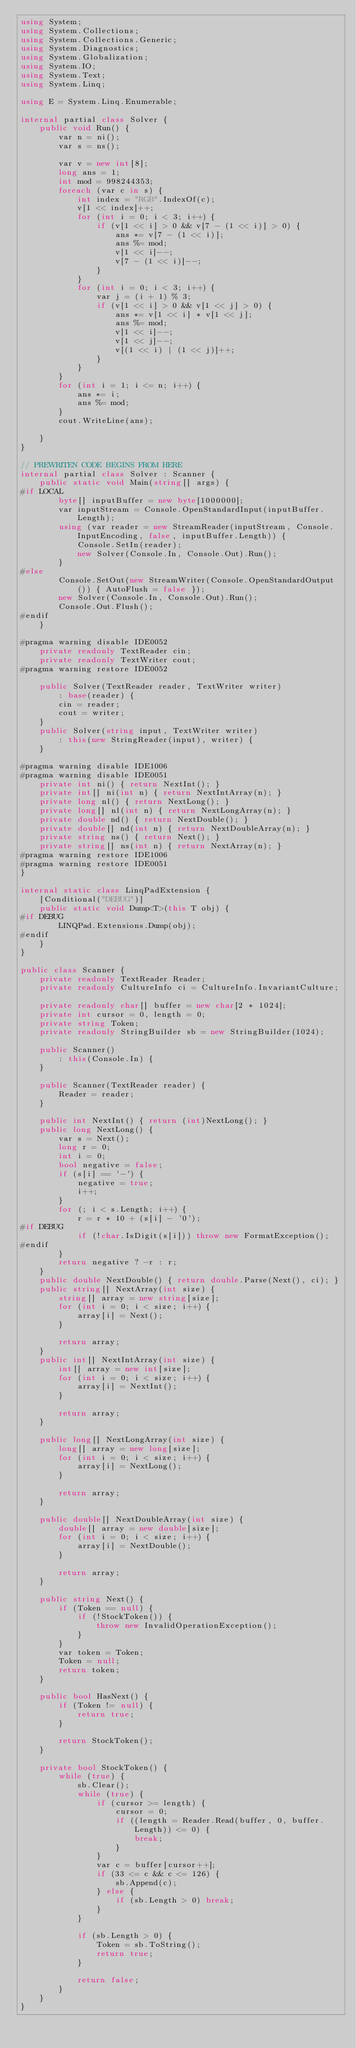<code> <loc_0><loc_0><loc_500><loc_500><_C#_>using System;
using System.Collections;
using System.Collections.Generic;
using System.Diagnostics;
using System.Globalization;
using System.IO;
using System.Text;
using System.Linq;

using E = System.Linq.Enumerable;

internal partial class Solver {
    public void Run() {
        var n = ni();
        var s = ns();

        var v = new int[8];
        long ans = 1;
        int mod = 998244353;
        foreach (var c in s) {
            int index = "RGB".IndexOf(c);
            v[1 << index]++;
            for (int i = 0; i < 3; i++) {
                if (v[1 << i] > 0 && v[7 - (1 << i)] > 0) {
                    ans *= v[7 - (1 << i)];
                    ans %= mod;
                    v[1 << i]--;
                    v[7 - (1 << i)]--;
                }
            }
            for (int i = 0; i < 3; i++) {
                var j = (i + 1) % 3;
                if (v[1 << i] > 0 && v[1 << j] > 0) {
                    ans *= v[1 << i] * v[1 << j];
                    ans %= mod;
                    v[1 << i]--;
                    v[1 << j]--;
                    v[(1 << i) | (1 << j)]++;
                }
            }
        }
        for (int i = 1; i <= n; i++) {
            ans *= i;
            ans %= mod;
        }
        cout.WriteLine(ans);

    }
}

// PREWRITEN CODE BEGINS FROM HERE
internal partial class Solver : Scanner {
    public static void Main(string[] args) {
#if LOCAL
        byte[] inputBuffer = new byte[1000000];
        var inputStream = Console.OpenStandardInput(inputBuffer.Length);
        using (var reader = new StreamReader(inputStream, Console.InputEncoding, false, inputBuffer.Length)) {
            Console.SetIn(reader);
            new Solver(Console.In, Console.Out).Run();
        }
#else
        Console.SetOut(new StreamWriter(Console.OpenStandardOutput()) { AutoFlush = false });
        new Solver(Console.In, Console.Out).Run();
        Console.Out.Flush();
#endif
    }

#pragma warning disable IDE0052
    private readonly TextReader cin;
    private readonly TextWriter cout;
#pragma warning restore IDE0052

    public Solver(TextReader reader, TextWriter writer)
        : base(reader) {
        cin = reader;
        cout = writer;
    }
    public Solver(string input, TextWriter writer)
        : this(new StringReader(input), writer) {
    }

#pragma warning disable IDE1006
#pragma warning disable IDE0051
    private int ni() { return NextInt(); }
    private int[] ni(int n) { return NextIntArray(n); }
    private long nl() { return NextLong(); }
    private long[] nl(int n) { return NextLongArray(n); }
    private double nd() { return NextDouble(); }
    private double[] nd(int n) { return NextDoubleArray(n); }
    private string ns() { return Next(); }
    private string[] ns(int n) { return NextArray(n); }
#pragma warning restore IDE1006
#pragma warning restore IDE0051
}

internal static class LinqPadExtension {
    [Conditional("DEBUG")]
    public static void Dump<T>(this T obj) {
#if DEBUG
        LINQPad.Extensions.Dump(obj);
#endif
    }
}

public class Scanner {
    private readonly TextReader Reader;
    private readonly CultureInfo ci = CultureInfo.InvariantCulture;

    private readonly char[] buffer = new char[2 * 1024];
    private int cursor = 0, length = 0;
    private string Token;
    private readonly StringBuilder sb = new StringBuilder(1024);

    public Scanner()
        : this(Console.In) {
    }

    public Scanner(TextReader reader) {
        Reader = reader;
    }

    public int NextInt() { return (int)NextLong(); }
    public long NextLong() {
        var s = Next();
        long r = 0;
        int i = 0;
        bool negative = false;
        if (s[i] == '-') {
            negative = true;
            i++;
        }
        for (; i < s.Length; i++) {
            r = r * 10 + (s[i] - '0');
#if DEBUG
            if (!char.IsDigit(s[i])) throw new FormatException();
#endif
        }
        return negative ? -r : r;
    }
    public double NextDouble() { return double.Parse(Next(), ci); }
    public string[] NextArray(int size) {
        string[] array = new string[size];
        for (int i = 0; i < size; i++) {
            array[i] = Next();
        }

        return array;
    }
    public int[] NextIntArray(int size) {
        int[] array = new int[size];
        for (int i = 0; i < size; i++) {
            array[i] = NextInt();
        }

        return array;
    }

    public long[] NextLongArray(int size) {
        long[] array = new long[size];
        for (int i = 0; i < size; i++) {
            array[i] = NextLong();
        }

        return array;
    }

    public double[] NextDoubleArray(int size) {
        double[] array = new double[size];
        for (int i = 0; i < size; i++) {
            array[i] = NextDouble();
        }

        return array;
    }

    public string Next() {
        if (Token == null) {
            if (!StockToken()) {
                throw new InvalidOperationException();
            }
        }
        var token = Token;
        Token = null;
        return token;
    }

    public bool HasNext() {
        if (Token != null) {
            return true;
        }

        return StockToken();
    }

    private bool StockToken() {
        while (true) {
            sb.Clear();
            while (true) {
                if (cursor >= length) {
                    cursor = 0;
                    if ((length = Reader.Read(buffer, 0, buffer.Length)) <= 0) {
                        break;
                    }
                }
                var c = buffer[cursor++];
                if (33 <= c && c <= 126) {
                    sb.Append(c);
                } else {
                    if (sb.Length > 0) break;
                }
            }

            if (sb.Length > 0) {
                Token = sb.ToString();
                return true;
            }

            return false;
        }
    }
}</code> 